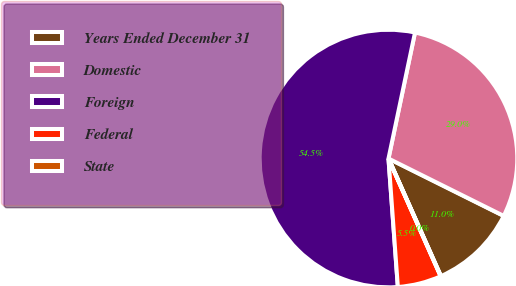<chart> <loc_0><loc_0><loc_500><loc_500><pie_chart><fcel>Years Ended December 31<fcel>Domestic<fcel>Foreign<fcel>Federal<fcel>State<nl><fcel>10.97%<fcel>29.05%<fcel>54.46%<fcel>5.48%<fcel>0.04%<nl></chart> 